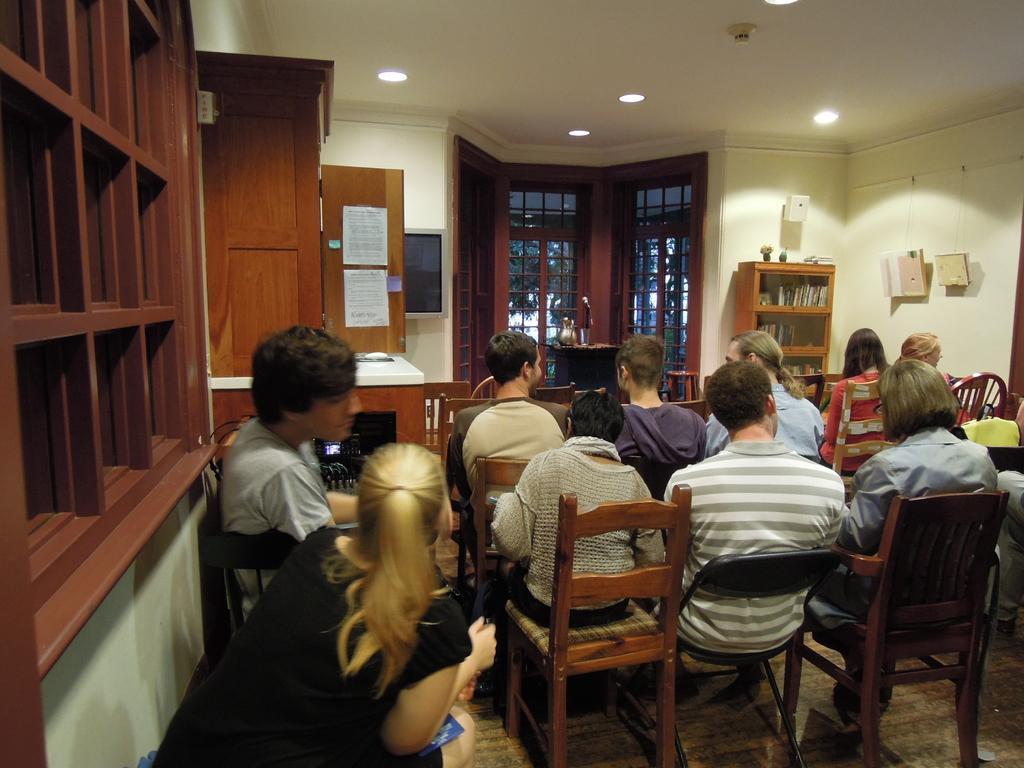Could you give a brief overview of what you see in this image? It is a room study room there are few people sitting in the chairs, in front of them there is a table beside the table there is a book shelf there are also few speakers fit to the wall , to the left side there is a big cupboard to the right side of the cupboard there is a window, to the roof there are some lights. 